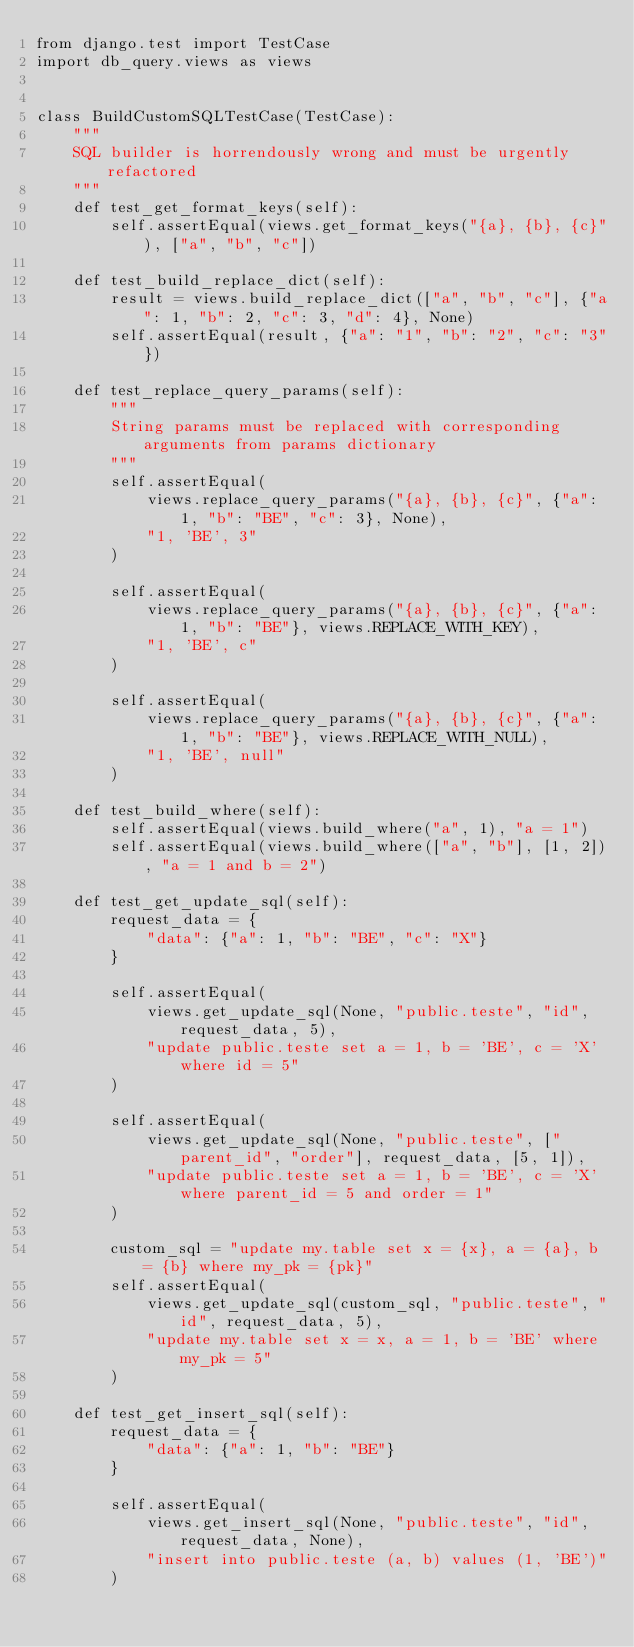<code> <loc_0><loc_0><loc_500><loc_500><_Python_>from django.test import TestCase
import db_query.views as views


class BuildCustomSQLTestCase(TestCase):
    """
    SQL builder is horrendously wrong and must be urgently refactored
    """
    def test_get_format_keys(self):
        self.assertEqual(views.get_format_keys("{a}, {b}, {c}"), ["a", "b", "c"])

    def test_build_replace_dict(self):
        result = views.build_replace_dict(["a", "b", "c"], {"a": 1, "b": 2, "c": 3, "d": 4}, None)
        self.assertEqual(result, {"a": "1", "b": "2", "c": "3"})

    def test_replace_query_params(self):
        """
        String params must be replaced with corresponding arguments from params dictionary
        """
        self.assertEqual(
            views.replace_query_params("{a}, {b}, {c}", {"a": 1, "b": "BE", "c": 3}, None),
            "1, 'BE', 3"
        )

        self.assertEqual(
            views.replace_query_params("{a}, {b}, {c}", {"a": 1, "b": "BE"}, views.REPLACE_WITH_KEY),
            "1, 'BE', c"
        )

        self.assertEqual(
            views.replace_query_params("{a}, {b}, {c}", {"a": 1, "b": "BE"}, views.REPLACE_WITH_NULL),
            "1, 'BE', null"
        )

    def test_build_where(self):
        self.assertEqual(views.build_where("a", 1), "a = 1")
        self.assertEqual(views.build_where(["a", "b"], [1, 2]), "a = 1 and b = 2")

    def test_get_update_sql(self):
        request_data = {
            "data": {"a": 1, "b": "BE", "c": "X"}
        }

        self.assertEqual(
            views.get_update_sql(None, "public.teste", "id", request_data, 5),
            "update public.teste set a = 1, b = 'BE', c = 'X' where id = 5"
        )

        self.assertEqual(
            views.get_update_sql(None, "public.teste", ["parent_id", "order"], request_data, [5, 1]),
            "update public.teste set a = 1, b = 'BE', c = 'X' where parent_id = 5 and order = 1"
        )

        custom_sql = "update my.table set x = {x}, a = {a}, b = {b} where my_pk = {pk}"
        self.assertEqual(
            views.get_update_sql(custom_sql, "public.teste", "id", request_data, 5),
            "update my.table set x = x, a = 1, b = 'BE' where my_pk = 5"
        )

    def test_get_insert_sql(self):
        request_data = {
            "data": {"a": 1, "b": "BE"}
        }

        self.assertEqual(
            views.get_insert_sql(None, "public.teste", "id", request_data, None),
            "insert into public.teste (a, b) values (1, 'BE')"
        )
</code> 